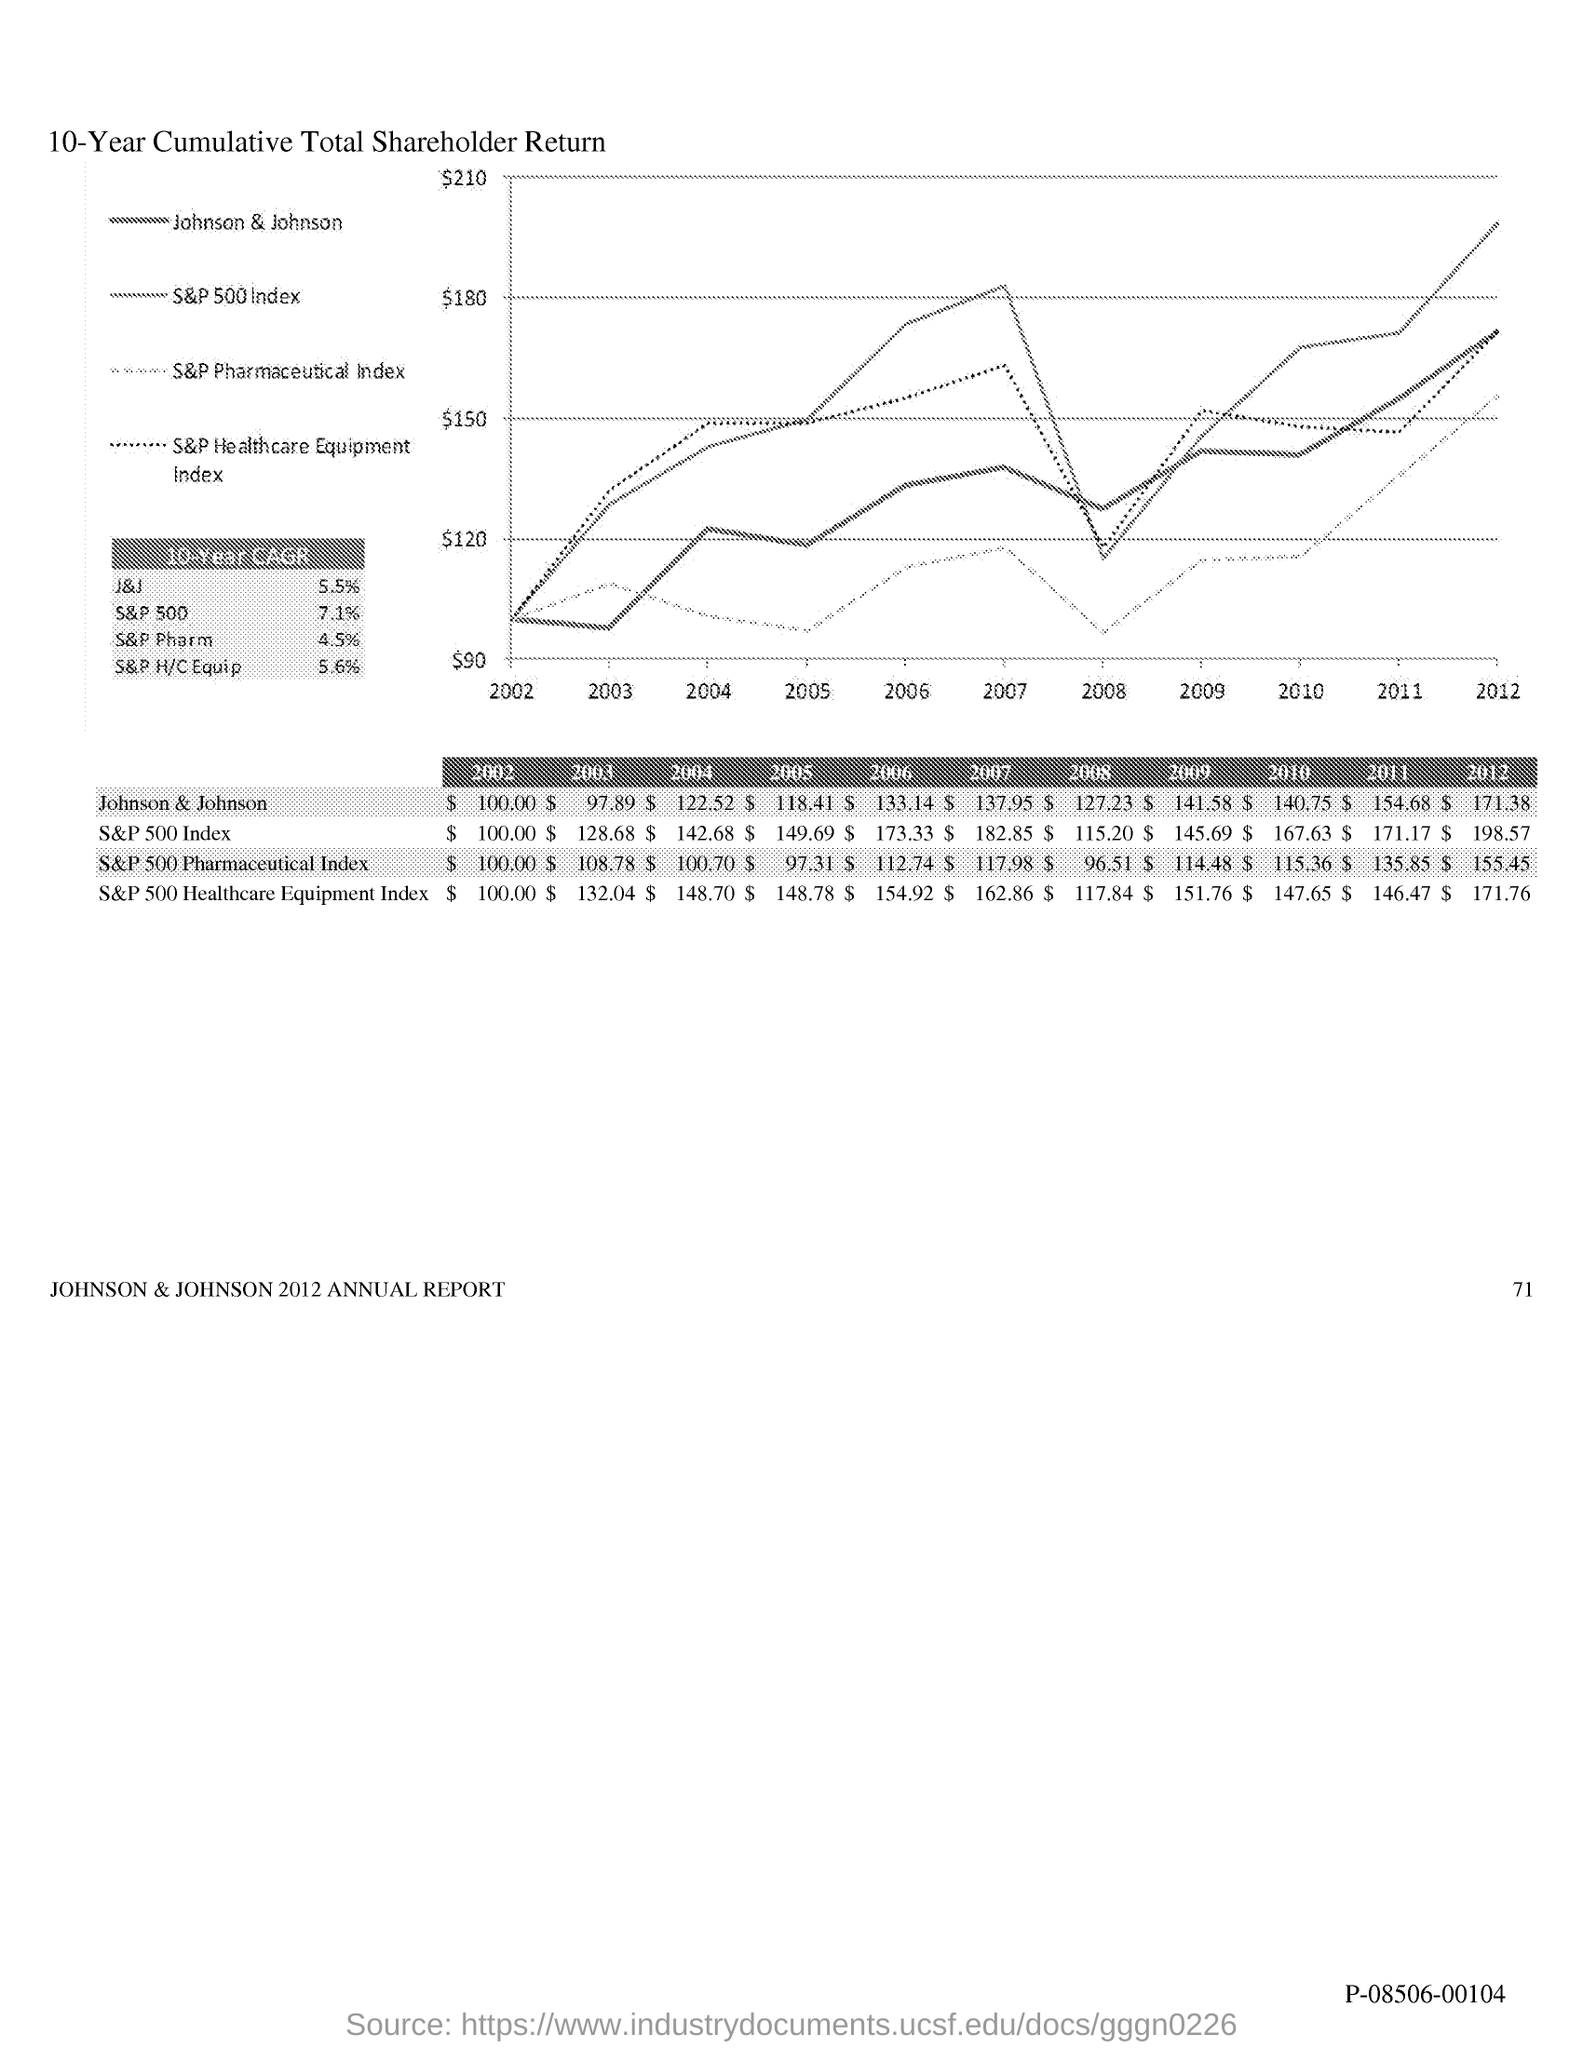Point out several critical features in this image. Johnson & Johnson was valued at $118.41 in 2005. In 2004, the value of Johnson & Johnson was $122.52. In 2010, the value of Johnson & Johnson was $140.75. As of 2007, the value of Johnson & Johnson was $137.95. Johnson & Johnson was valued at $141.58 in 2009. 